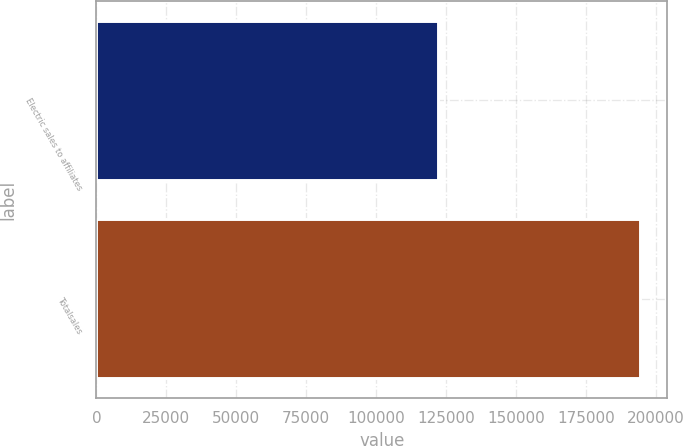<chart> <loc_0><loc_0><loc_500><loc_500><bar_chart><fcel>Electric sales to affiliates<fcel>Totalsales<nl><fcel>121961<fcel>194337<nl></chart> 